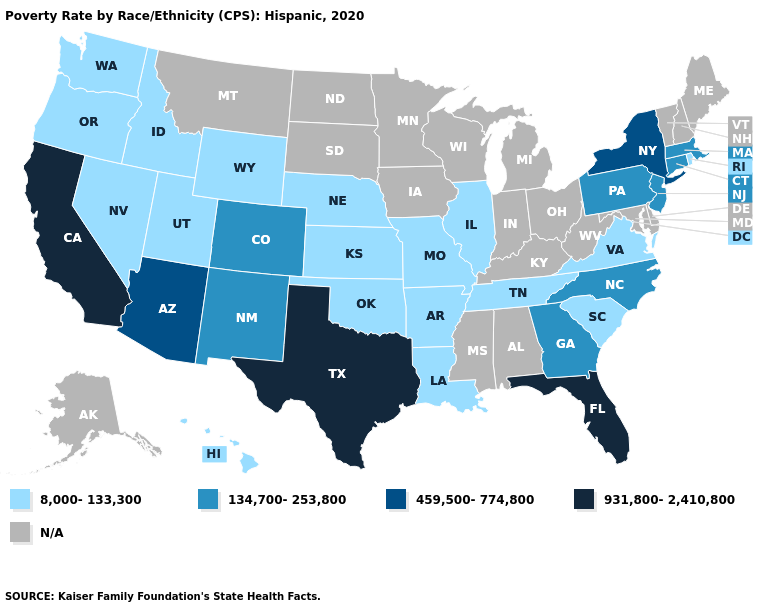What is the value of Kansas?
Answer briefly. 8,000-133,300. Does Massachusetts have the highest value in the Northeast?
Concise answer only. No. Name the states that have a value in the range N/A?
Short answer required. Alabama, Alaska, Delaware, Indiana, Iowa, Kentucky, Maine, Maryland, Michigan, Minnesota, Mississippi, Montana, New Hampshire, North Dakota, Ohio, South Dakota, Vermont, West Virginia, Wisconsin. What is the value of Georgia?
Give a very brief answer. 134,700-253,800. Does Florida have the highest value in the USA?
Keep it brief. Yes. Name the states that have a value in the range 134,700-253,800?
Concise answer only. Colorado, Connecticut, Georgia, Massachusetts, New Jersey, New Mexico, North Carolina, Pennsylvania. Name the states that have a value in the range N/A?
Quick response, please. Alabama, Alaska, Delaware, Indiana, Iowa, Kentucky, Maine, Maryland, Michigan, Minnesota, Mississippi, Montana, New Hampshire, North Dakota, Ohio, South Dakota, Vermont, West Virginia, Wisconsin. Name the states that have a value in the range N/A?
Short answer required. Alabama, Alaska, Delaware, Indiana, Iowa, Kentucky, Maine, Maryland, Michigan, Minnesota, Mississippi, Montana, New Hampshire, North Dakota, Ohio, South Dakota, Vermont, West Virginia, Wisconsin. What is the value of Connecticut?
Be succinct. 134,700-253,800. What is the value of Nebraska?
Short answer required. 8,000-133,300. Among the states that border Connecticut , which have the highest value?
Short answer required. New York. What is the highest value in states that border Nebraska?
Keep it brief. 134,700-253,800. 